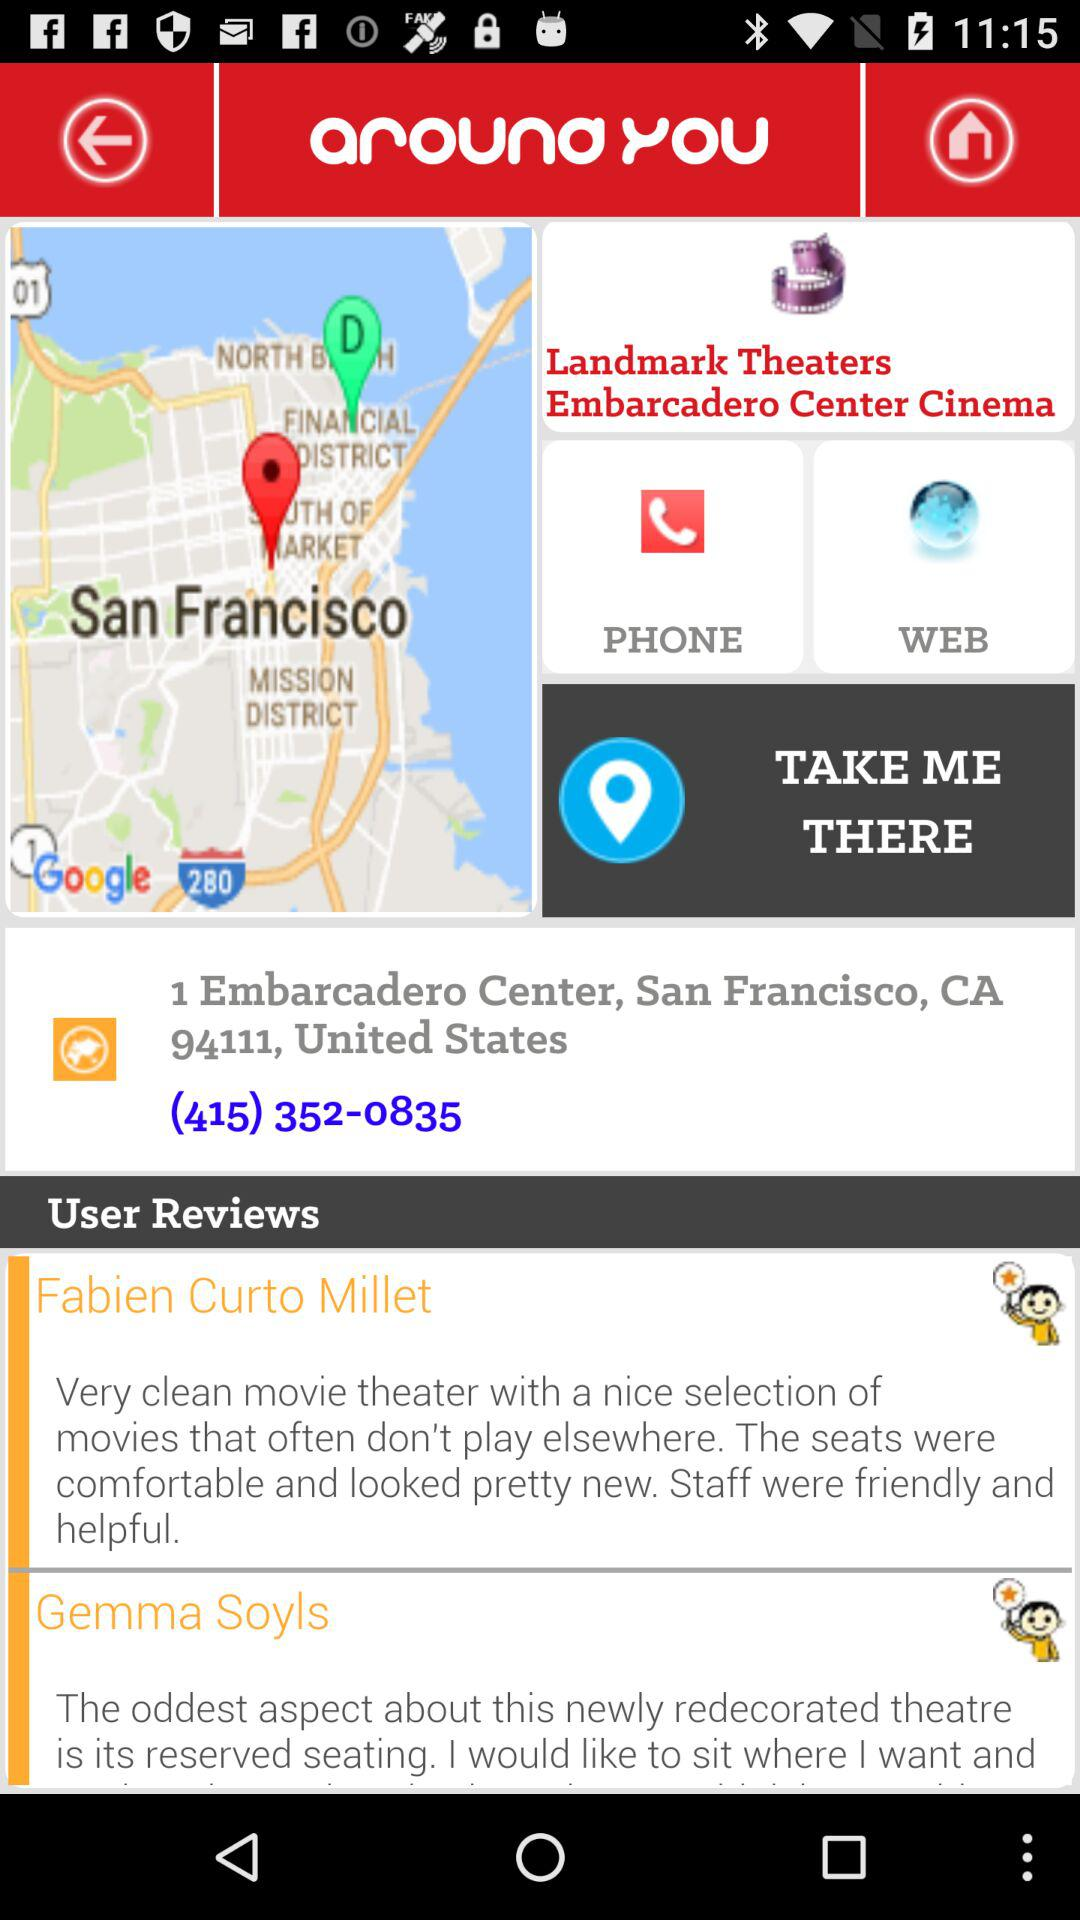What is the theater name? The theater name is "Landmark Theaters Embarcadero Center Cinema". 